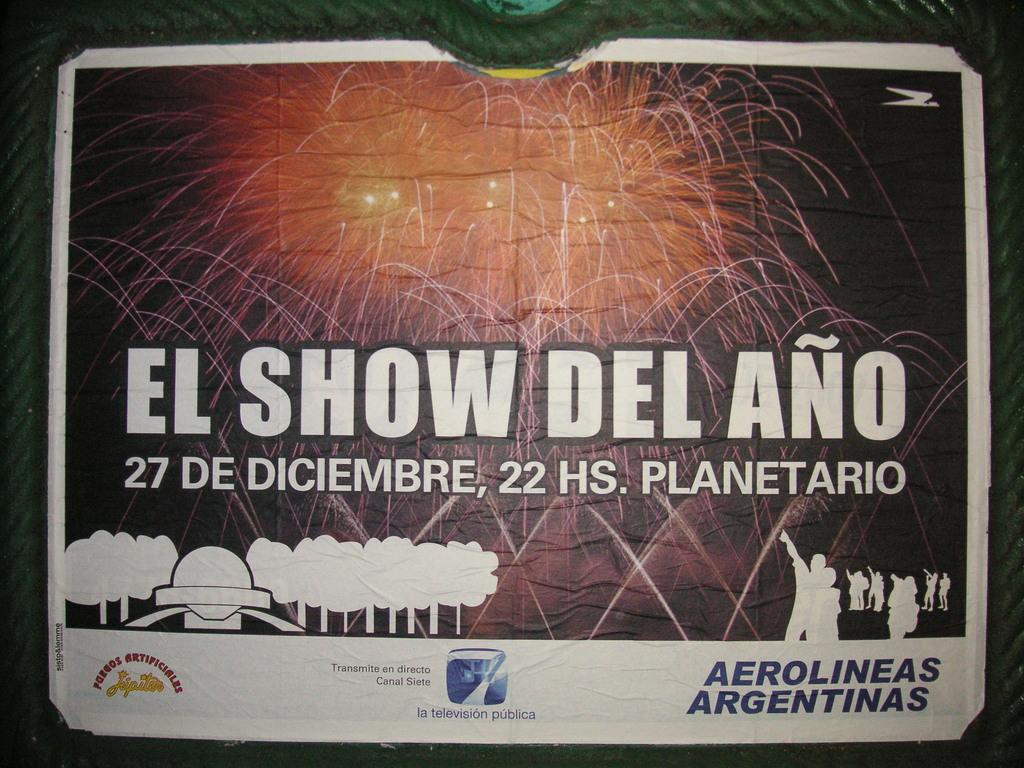<image>
Render a clear and concise summary of the photo. Fireworks are shown with the text of El Show del ano. 